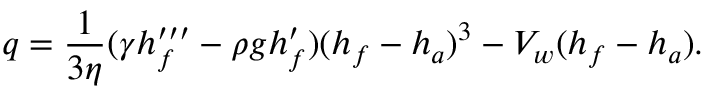Convert formula to latex. <formula><loc_0><loc_0><loc_500><loc_500>q = { \frac { 1 } { 3 \eta } } ( \gamma h _ { f } ^ { \prime \prime \prime } - \rho g h _ { f } ^ { \prime } ) ( h _ { f } - h _ { a } ) ^ { 3 } - V _ { w } ( h _ { f } - h _ { a } ) .</formula> 